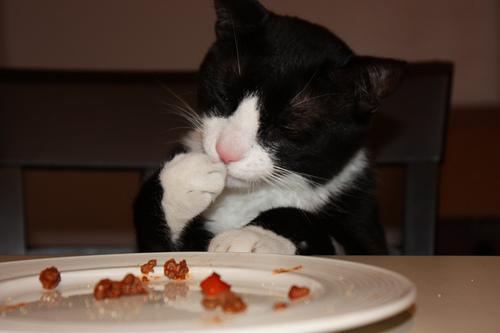How many cats are in the picture?
Give a very brief answer. 1. 